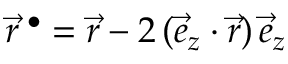<formula> <loc_0><loc_0><loc_500><loc_500>\vec { r } ^ { \, \bullet } = \vec { r } - 2 \, ( \vec { e } _ { z } \cdot \vec { r } ) \, \vec { e } _ { z }</formula> 